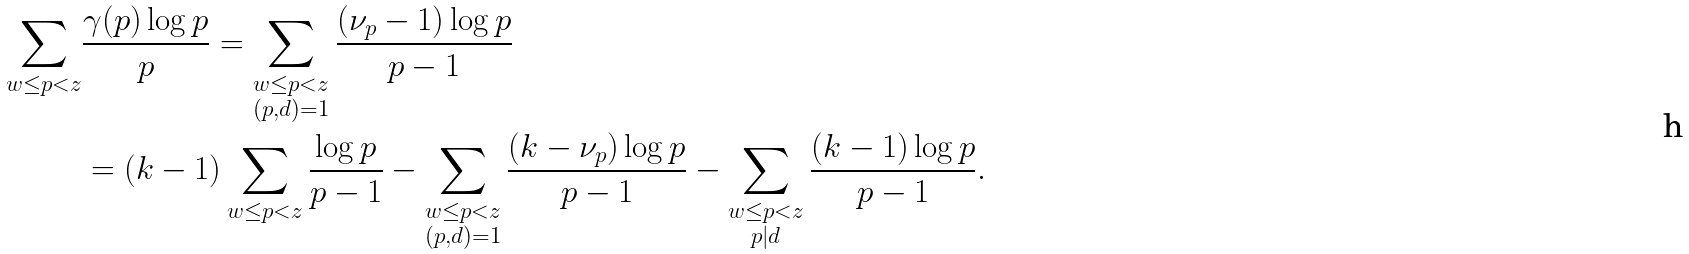<formula> <loc_0><loc_0><loc_500><loc_500>\sum _ { w \leq p < z } & \frac { \gamma ( p ) \log p } { p } = \sum _ { \substack { w \leq p < z \\ ( p , d ) = 1 } } \frac { ( \nu _ { p } - 1 ) \log p } { p - 1 } \\ & = ( k - 1 ) \sum _ { w \leq p < z } \frac { \log p } { p - 1 } - \sum _ { \substack { w \leq p < z \\ ( p , d ) = 1 } } \frac { ( k - \nu _ { p } ) \log p } { p - 1 } - \sum _ { \substack { w \leq p < z \\ p | d } } \frac { ( k - 1 ) \log p } { p - 1 } .</formula> 